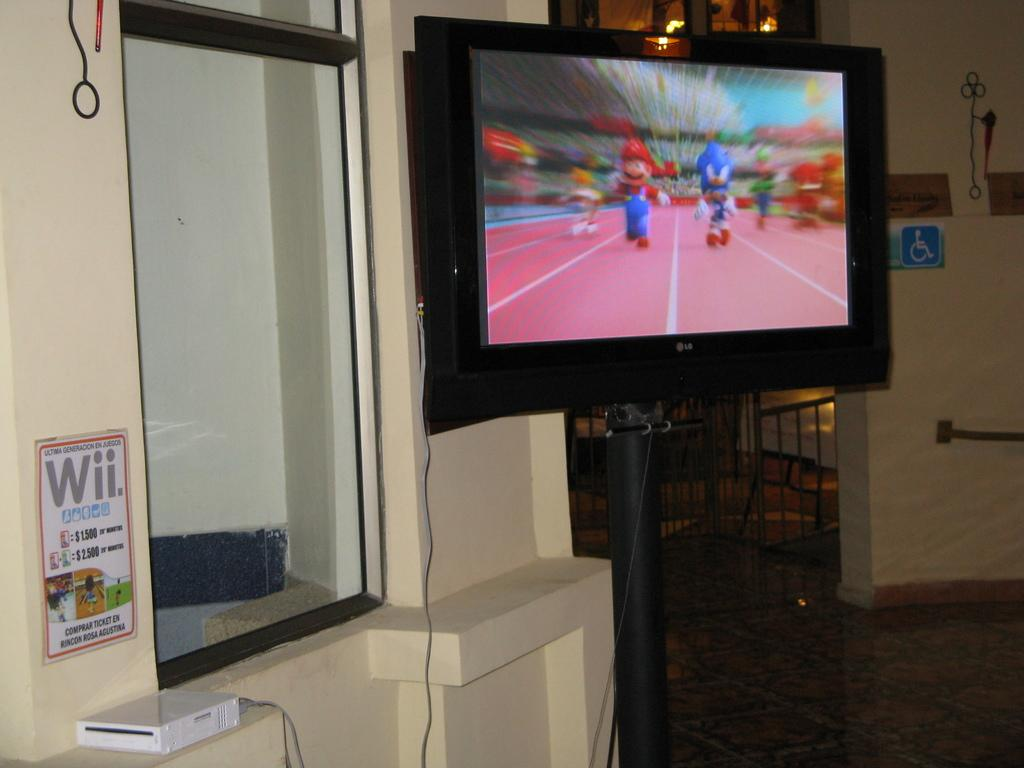<image>
Provide a brief description of the given image. A Nintendo Wii connected to a flat screen television in a public area. 